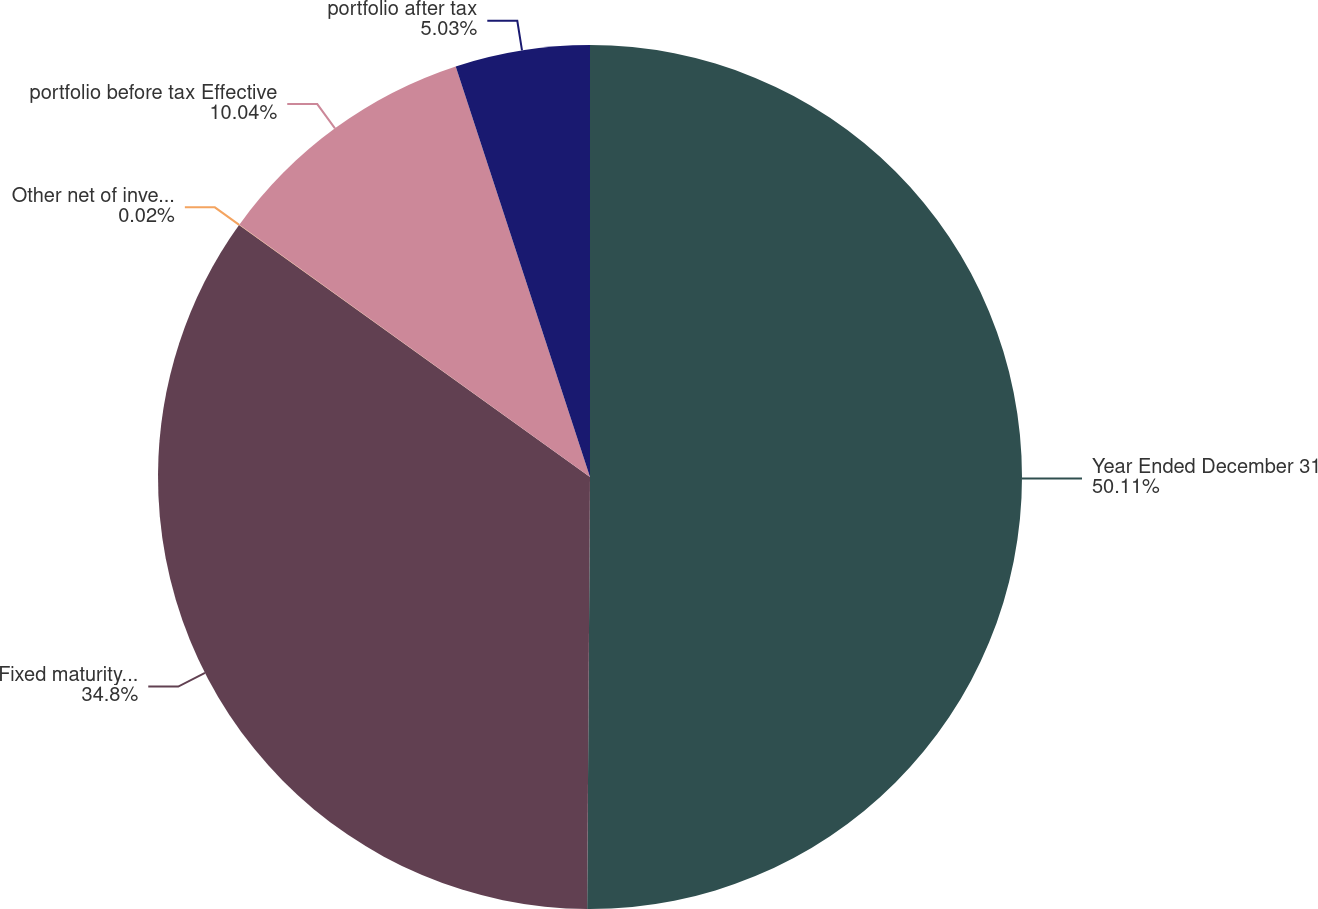Convert chart to OTSL. <chart><loc_0><loc_0><loc_500><loc_500><pie_chart><fcel>Year Ended December 31<fcel>Fixed maturity securities<fcel>Other net of investment<fcel>portfolio before tax Effective<fcel>portfolio after tax<nl><fcel>50.1%<fcel>34.8%<fcel>0.02%<fcel>10.04%<fcel>5.03%<nl></chart> 